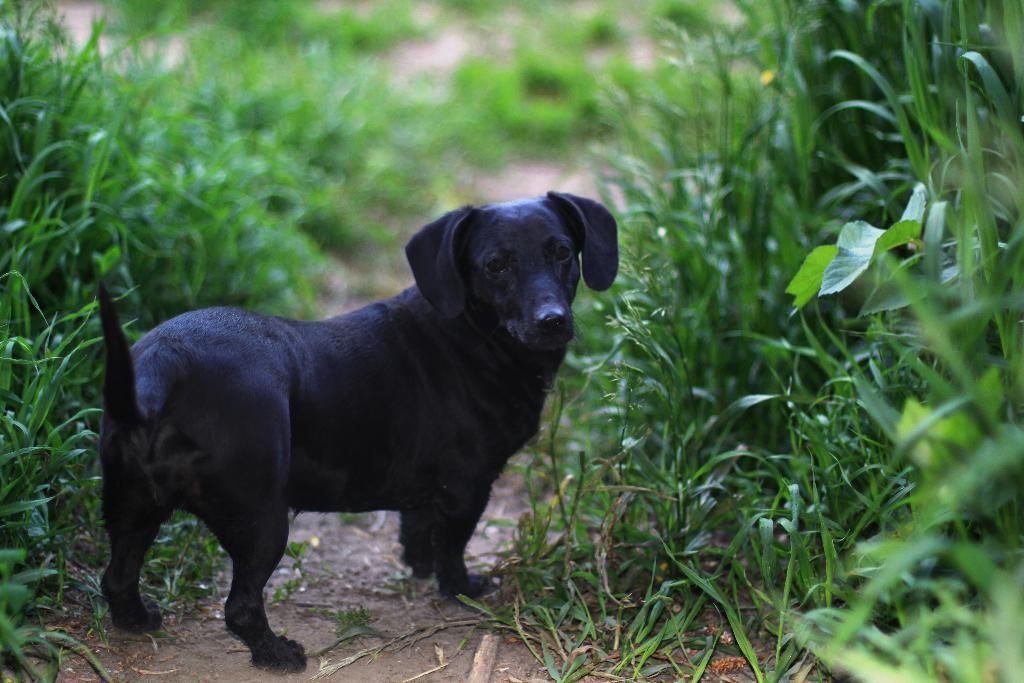In one or two sentences, can you explain what this image depicts? In this image there is a path, on that path there is a dog, on either side of the path there is grass. 